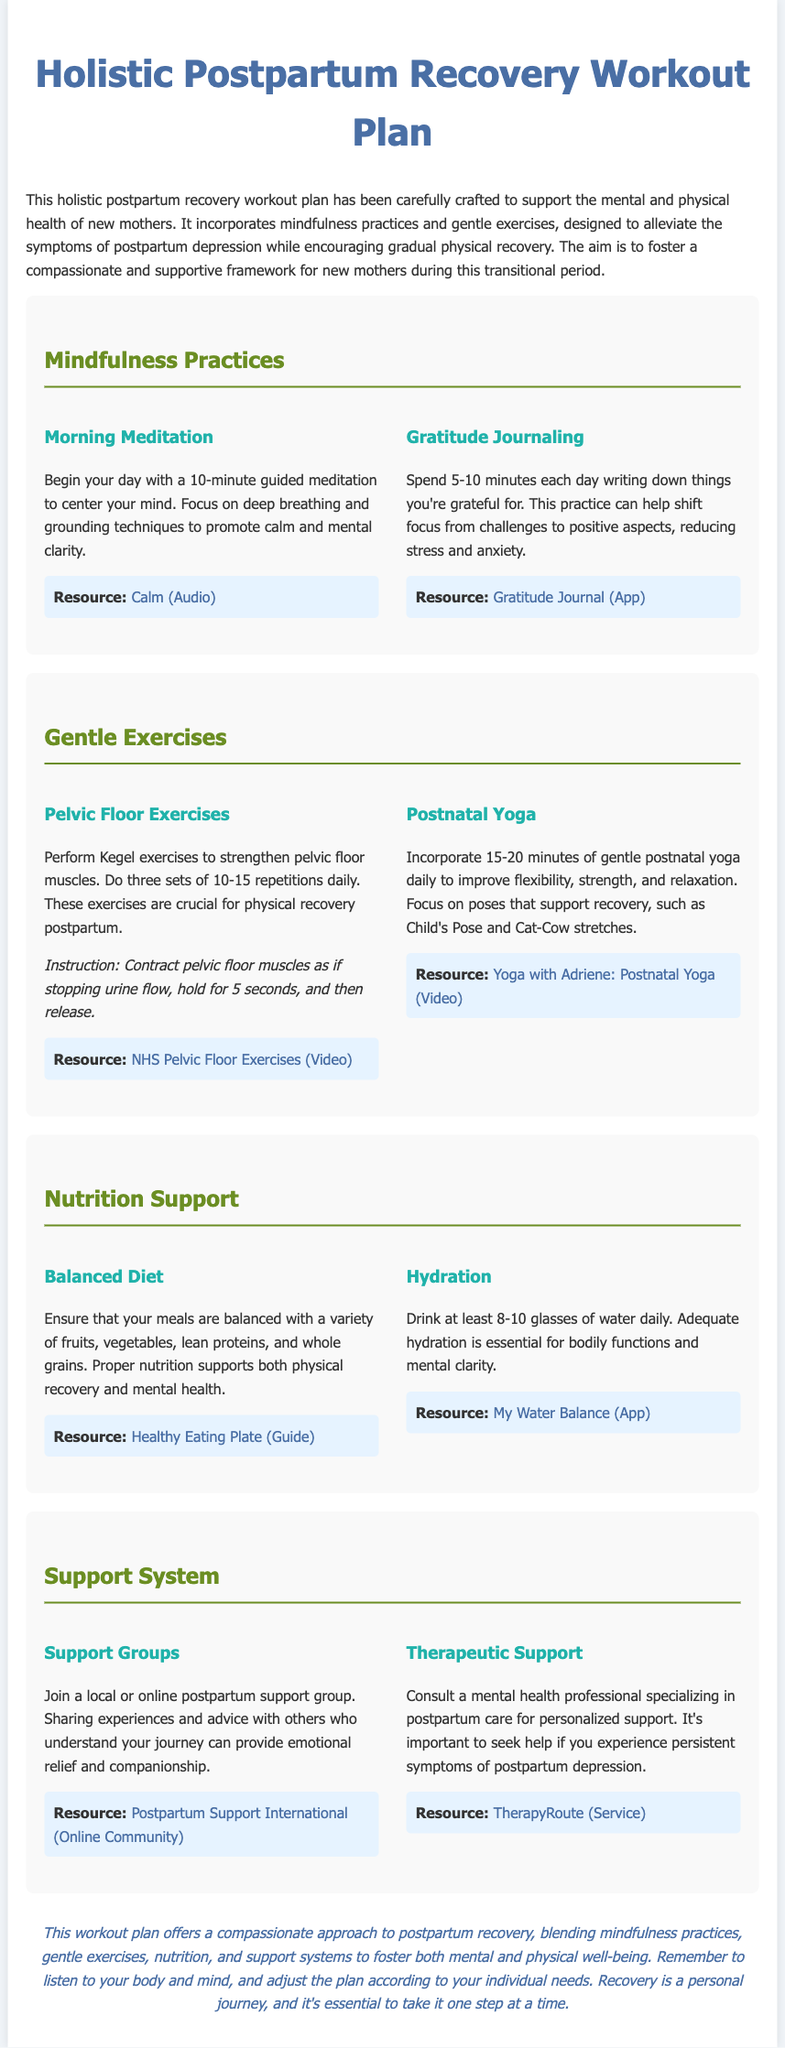What is the title of the document? The title of the document indicates its primary focus, which is found in the header tag.
Answer: Holistic Postpartum Recovery Workout Plan How long should morning meditation last? The duration of the morning meditation practice is specified.
Answer: 10 minutes What type of exercises are included for pelvic floor recovery? The document specifies the type of exercise recommended for pelvic floor recovery.
Answer: Kegel exercises What is the recommended daily water intake? The document states a specific quantity for hydration needs.
Answer: 8-10 glasses How many repetitions of Kegel exercises should be performed? The number of repetitions for Kegel exercises is mentioned, essential for physical recovery.
Answer: 10-15 repetitions Which online community is recommended for postpartum support? The document lists a specific resource for postpartum support that can be accessed online.
Answer: Postpartum Support International What is a suggested mindfulness practice before starting the day? The document suggests a specific mindfulness practice to start the day positively.
Answer: Morning Meditation What is the main aim of the workout plan? The document explains the primary purpose of the workout plan in its introductory section.
Answer: Support mental and physical health of new mothers 